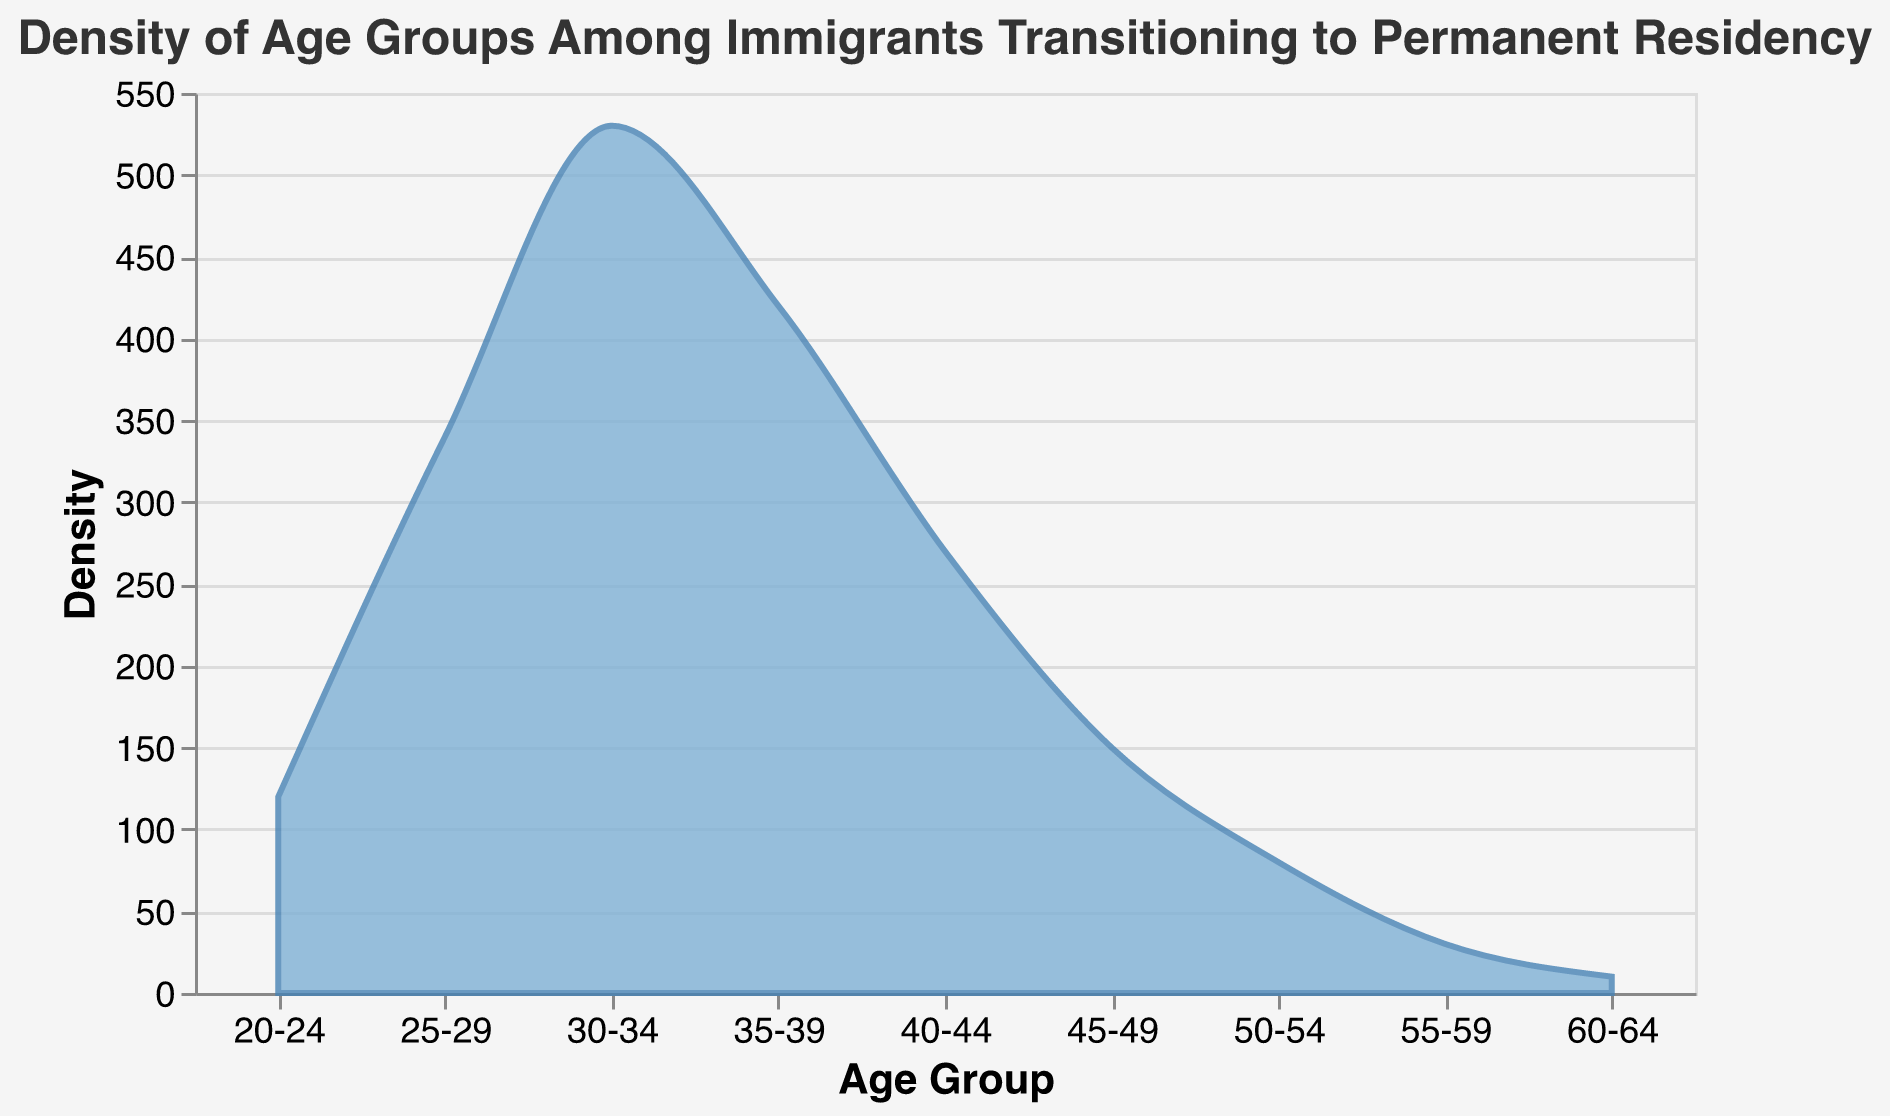What is the title of the figure? The title of the figure is usually displayed prominently at the top. By reading it directly from the visual, we can determine the exact wording used.
Answer: Density of Age Groups Among Immigrants Transitioning to Permanent Residency Which age group has the highest density of immigrants transitioning to permanent residency? By looking at the peak of the density plot, we can identify the age group where the count is the highest
Answer: 30-34 What is the density for the age group 45-49? Locate the point corresponding to the age group 45-49 on the x-axis and then check the y-axis value for that point.
Answer: 150 How many age groups have a density count of more than 300? Count the number of age groups where the density value exceeds 300 on the y-axis.
Answer: 3 Which age groups have a density less than or equal to 150? Identify the age groups that fall at or below the 150 mark on the y-axis and list them.
Answer: 20-24, 45-49, 50-54, 55-59, 60-64 Compare the densities of age groups 20-24 and 50-54. Which one is higher? Look at the density values for the age groups 20-24 and 50-54 and compare them to see which is greater.
Answer: 20-24 How does the density trend change from age group 35-39 to 50-54? Observe the density values starting from age group 35-39 and moving to 50-54, noting the increase or decrease.
Answer: Decrease What is the cumulative density of the immigrants in age groups 25-29 and 40-44? Sum the densities of the age groups 25-29 and 40-44 to get the cumulative density.
Answer: 340 + 270 = 610 Which age group has the least density among the immigrants transitioning to permanent residency? Locate the minimum density value on the plot and identify the corresponding age group.
Answer: 60-64 What percentage of the total density does the age group 30-34 represent? First, sum all the densities to get the total, then divide the density of age group 30-34 by this total and multiply by 100.
Answer: (530 / 1950) * 100 ≈ 27.18% 